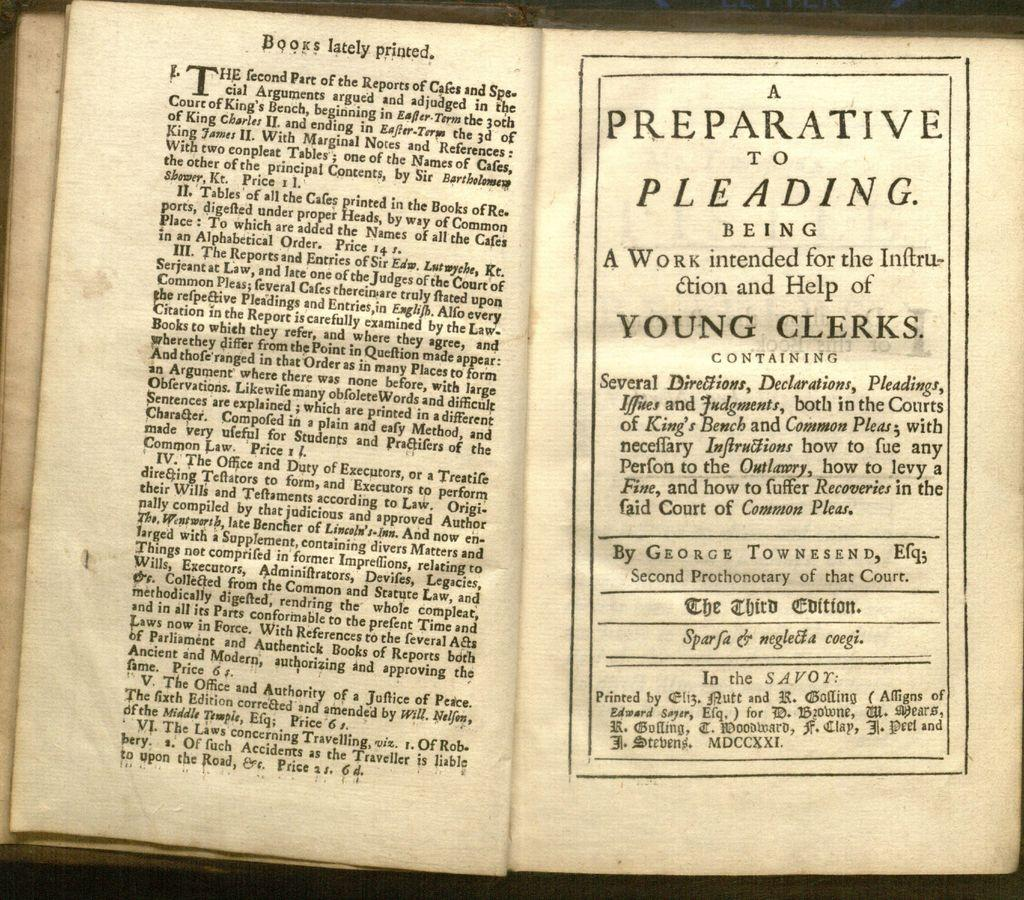<image>
Offer a succinct explanation of the picture presented. Books lately printed and A preparative to pleading with young clerks. 